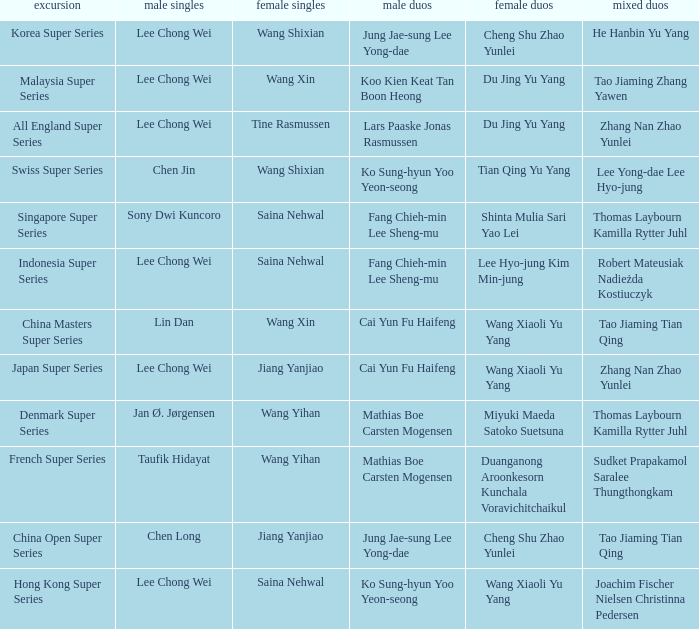Who were the womens doubles when the mixed doubles were zhang nan zhao yunlei on the tour all england super series? Du Jing Yu Yang. 